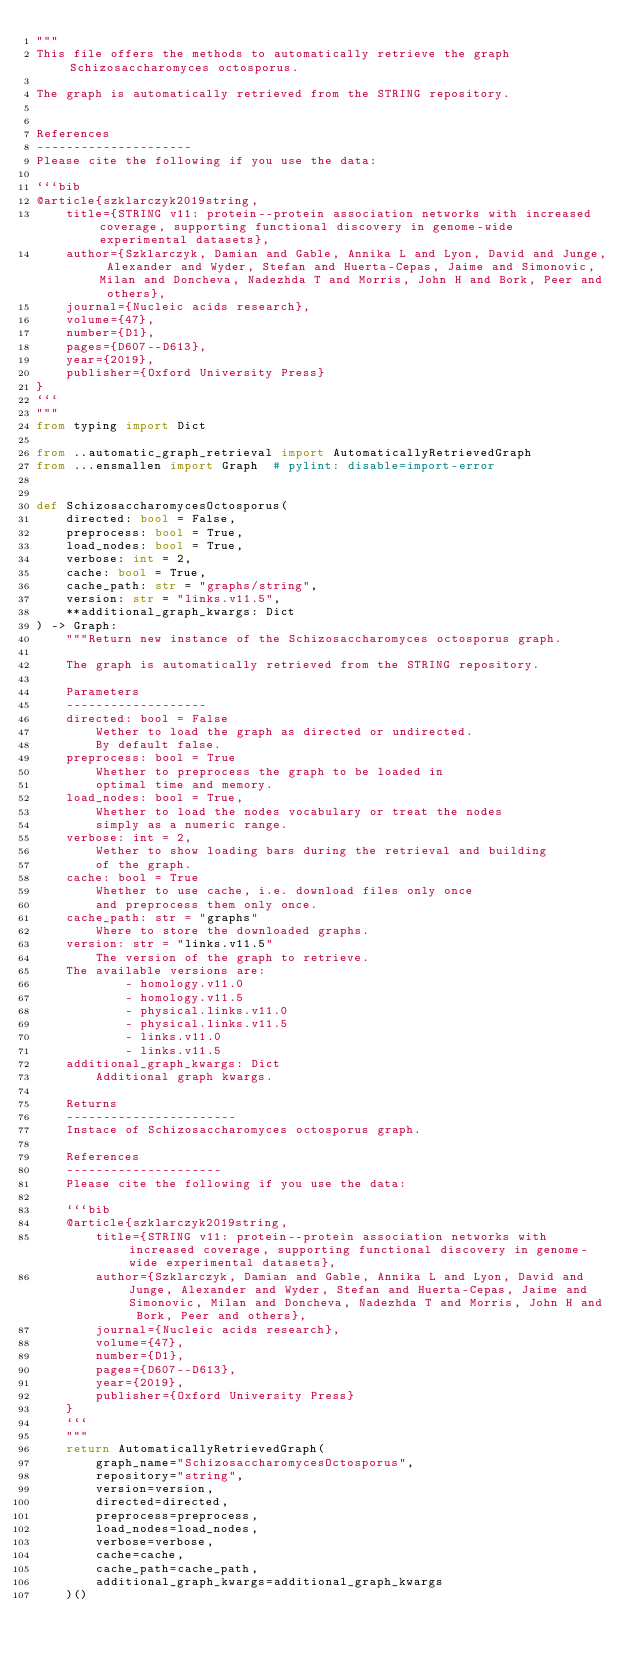Convert code to text. <code><loc_0><loc_0><loc_500><loc_500><_Python_>"""
This file offers the methods to automatically retrieve the graph Schizosaccharomyces octosporus.

The graph is automatically retrieved from the STRING repository. 


References
---------------------
Please cite the following if you use the data:

```bib
@article{szklarczyk2019string,
    title={STRING v11: protein--protein association networks with increased coverage, supporting functional discovery in genome-wide experimental datasets},
    author={Szklarczyk, Damian and Gable, Annika L and Lyon, David and Junge, Alexander and Wyder, Stefan and Huerta-Cepas, Jaime and Simonovic, Milan and Doncheva, Nadezhda T and Morris, John H and Bork, Peer and others},
    journal={Nucleic acids research},
    volume={47},
    number={D1},
    pages={D607--D613},
    year={2019},
    publisher={Oxford University Press}
}
```
"""
from typing import Dict

from ..automatic_graph_retrieval import AutomaticallyRetrievedGraph
from ...ensmallen import Graph  # pylint: disable=import-error


def SchizosaccharomycesOctosporus(
    directed: bool = False,
    preprocess: bool = True,
    load_nodes: bool = True,
    verbose: int = 2,
    cache: bool = True,
    cache_path: str = "graphs/string",
    version: str = "links.v11.5",
    **additional_graph_kwargs: Dict
) -> Graph:
    """Return new instance of the Schizosaccharomyces octosporus graph.

    The graph is automatically retrieved from the STRING repository.	

    Parameters
    -------------------
    directed: bool = False
        Wether to load the graph as directed or undirected.
        By default false.
    preprocess: bool = True
        Whether to preprocess the graph to be loaded in 
        optimal time and memory.
    load_nodes: bool = True,
        Whether to load the nodes vocabulary or treat the nodes
        simply as a numeric range.
    verbose: int = 2,
        Wether to show loading bars during the retrieval and building
        of the graph.
    cache: bool = True
        Whether to use cache, i.e. download files only once
        and preprocess them only once.
    cache_path: str = "graphs"
        Where to store the downloaded graphs.
    version: str = "links.v11.5"
        The version of the graph to retrieve.		
	The available versions are:
			- homology.v11.0
			- homology.v11.5
			- physical.links.v11.0
			- physical.links.v11.5
			- links.v11.0
			- links.v11.5
    additional_graph_kwargs: Dict
        Additional graph kwargs.

    Returns
    -----------------------
    Instace of Schizosaccharomyces octosporus graph.

	References
	---------------------
	Please cite the following if you use the data:
	
	```bib
	@article{szklarczyk2019string,
	    title={STRING v11: protein--protein association networks with increased coverage, supporting functional discovery in genome-wide experimental datasets},
	    author={Szklarczyk, Damian and Gable, Annika L and Lyon, David and Junge, Alexander and Wyder, Stefan and Huerta-Cepas, Jaime and Simonovic, Milan and Doncheva, Nadezhda T and Morris, John H and Bork, Peer and others},
	    journal={Nucleic acids research},
	    volume={47},
	    number={D1},
	    pages={D607--D613},
	    year={2019},
	    publisher={Oxford University Press}
	}
	```
    """
    return AutomaticallyRetrievedGraph(
        graph_name="SchizosaccharomycesOctosporus",
        repository="string",
        version=version,
        directed=directed,
        preprocess=preprocess,
        load_nodes=load_nodes,
        verbose=verbose,
        cache=cache,
        cache_path=cache_path,
        additional_graph_kwargs=additional_graph_kwargs
    )()
</code> 